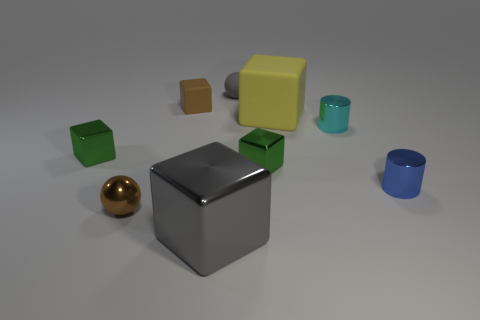There is a gray thing that is in front of the yellow thing; how many tiny brown cubes are in front of it?
Offer a terse response. 0. How many objects are either balls behind the tiny blue cylinder or small cyan rubber blocks?
Keep it short and to the point. 1. Is there a cyan shiny thing of the same shape as the brown shiny object?
Offer a very short reply. No. What shape is the tiny green thing that is right of the gray object in front of the tiny blue metal thing?
Give a very brief answer. Cube. What number of cubes are small things or gray objects?
Give a very brief answer. 4. There is a block that is the same color as the small rubber sphere; what is it made of?
Provide a succinct answer. Metal. There is a tiny brown object that is in front of the big yellow thing; is its shape the same as the gray thing that is in front of the blue thing?
Your response must be concise. No. What color is the tiny block that is in front of the brown matte thing and on the left side of the tiny gray rubber ball?
Offer a very short reply. Green. Do the big rubber cube and the tiny matte thing that is behind the small brown matte object have the same color?
Offer a terse response. No. There is a metal thing that is to the right of the big gray metal block and on the left side of the cyan shiny cylinder; how big is it?
Keep it short and to the point. Small. 